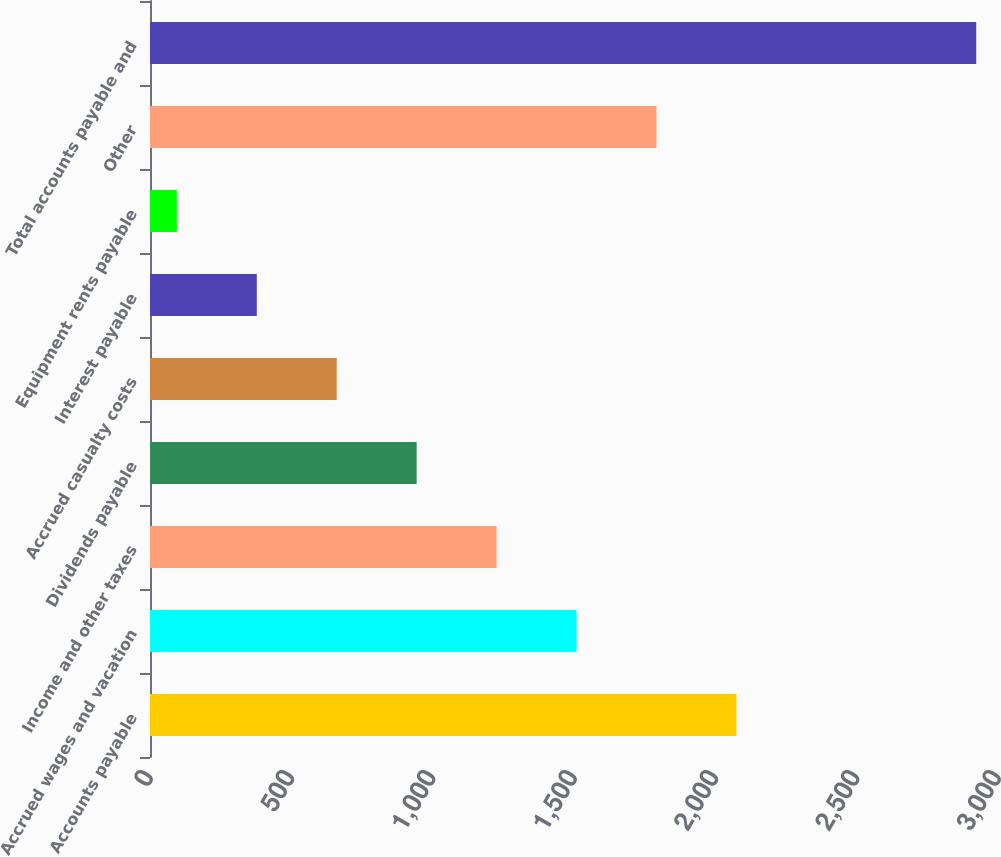Convert chart to OTSL. <chart><loc_0><loc_0><loc_500><loc_500><bar_chart><fcel>Accounts payable<fcel>Accrued wages and vacation<fcel>Income and other taxes<fcel>Dividends payable<fcel>Accrued casualty costs<fcel>Interest payable<fcel>Equipment rents payable<fcel>Other<fcel>Total accounts payable and<nl><fcel>2074.6<fcel>1509<fcel>1226.2<fcel>943.4<fcel>660.6<fcel>377.8<fcel>95<fcel>1791.8<fcel>2923<nl></chart> 